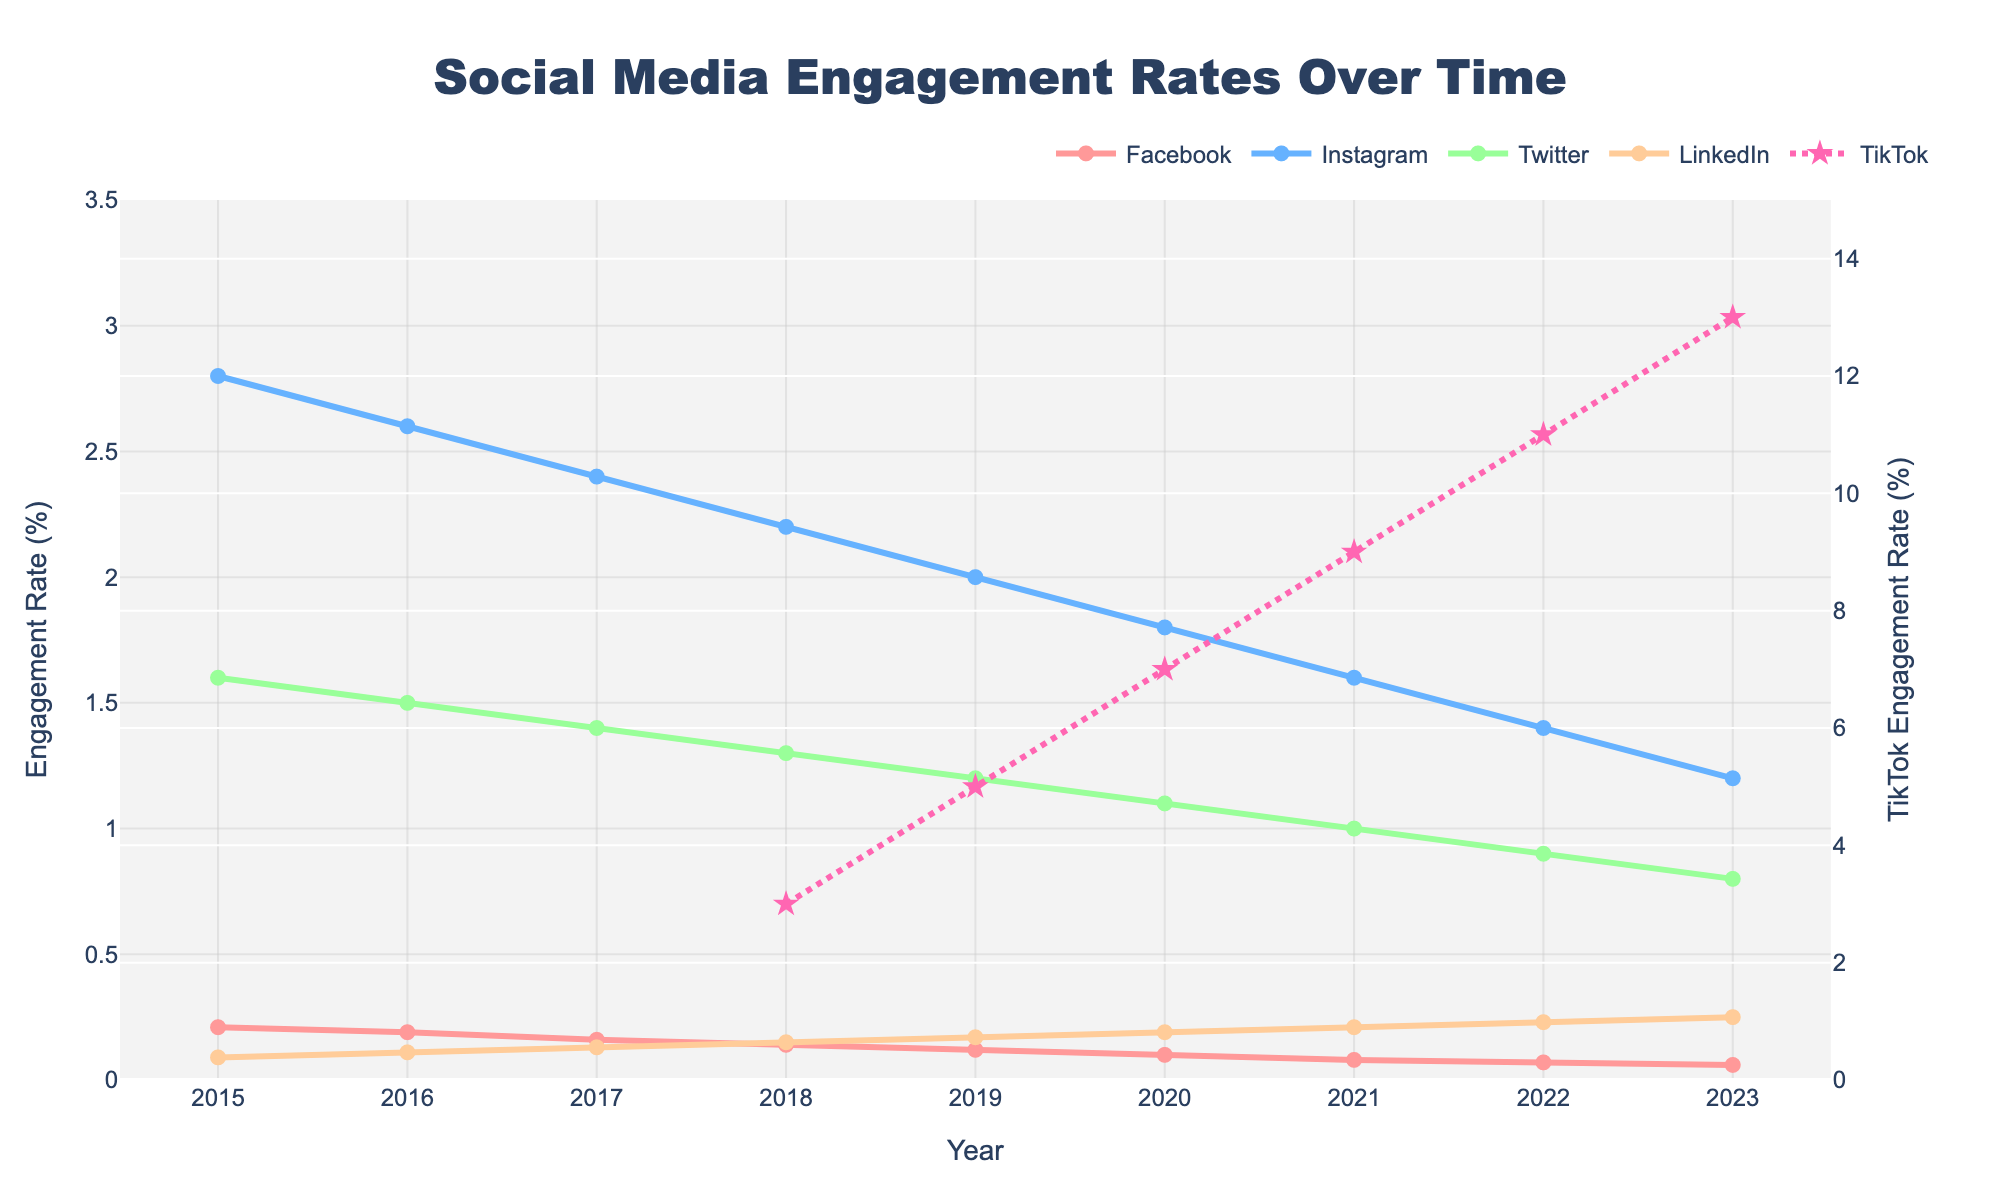What year did TikTok first appear in the data? TikTok first appears in the data in 2018, as indicated by "N/A" values before this year followed by a numeric engagement rate in 2018.
Answer: 2018 Which platform had the highest engagement rate in 2023? TikTok had an engagement rate of 13.00% in 2023, which is significantly higher than all other platforms.
Answer: TikTok How did the engagement rate of Instagram change from 2015 to 2023? Instagram's engagement rate decreased from 2.80% in 2015 to 1.20% in 2023. The difference is 2.80% - 1.20% = 1.60%.
Answer: Decreased by 1.60% Compare the engagement rates of Facebook and LinkedIn in 2017. Which one is higher and by how much? In 2017, Facebook had an engagement rate of 0.16%, while LinkedIn had an engagement rate of 0.13%. The difference is 0.16% - 0.13% = 0.03%.
Answer: Facebook, by 0.03% What is the average engagement rate of Twitter from 2015 to 2023? Calculate the average by summing the engagement rates from 2015 to 2023 and then dividing by the number of years: (1.60 + 1.50 + 1.40 + 1.30 + 1.20 + 1.10 + 1.00 + 0.90 + 0.80) / 9.
Answer: 1.20% In 2019, which platform had the second highest engagement rate? In 2019, TikTok had the highest engagement rate at 5.00%, followed by Instagram at 2.00%.
Answer: Instagram What is the visual difference between TikTok's and the other platforms' lines? TikTok's line is dotted and includes star-shaped markers, while the other platforms' lines are solid and include circle markers.
Answer: Dotted line with star markers How many platforms showed a decreasing trend in engagement rates from 2015 to 2023? Facebook, Instagram, Twitter, and LinkedIn all showed a decreasing trend in engagement rates from 2015 to 2023.
Answer: 4 What is the difference in engagement rates between the platform with the highest and the platform with the lowest engagement rates in 2021? In 2021, TikTok had the highest engagement rate at 9.00%, and Facebook had the lowest at 0.08%. The difference is 9.00% - 0.08% = 8.92%.
Answer: 8.92% Which platform had the least change in engagement rate over the years? LinkedIn went from 0.09% in 2015 to 0.25% in 2023, experiencing relatively small incremental changes compared to other platforms.
Answer: LinkedIn 